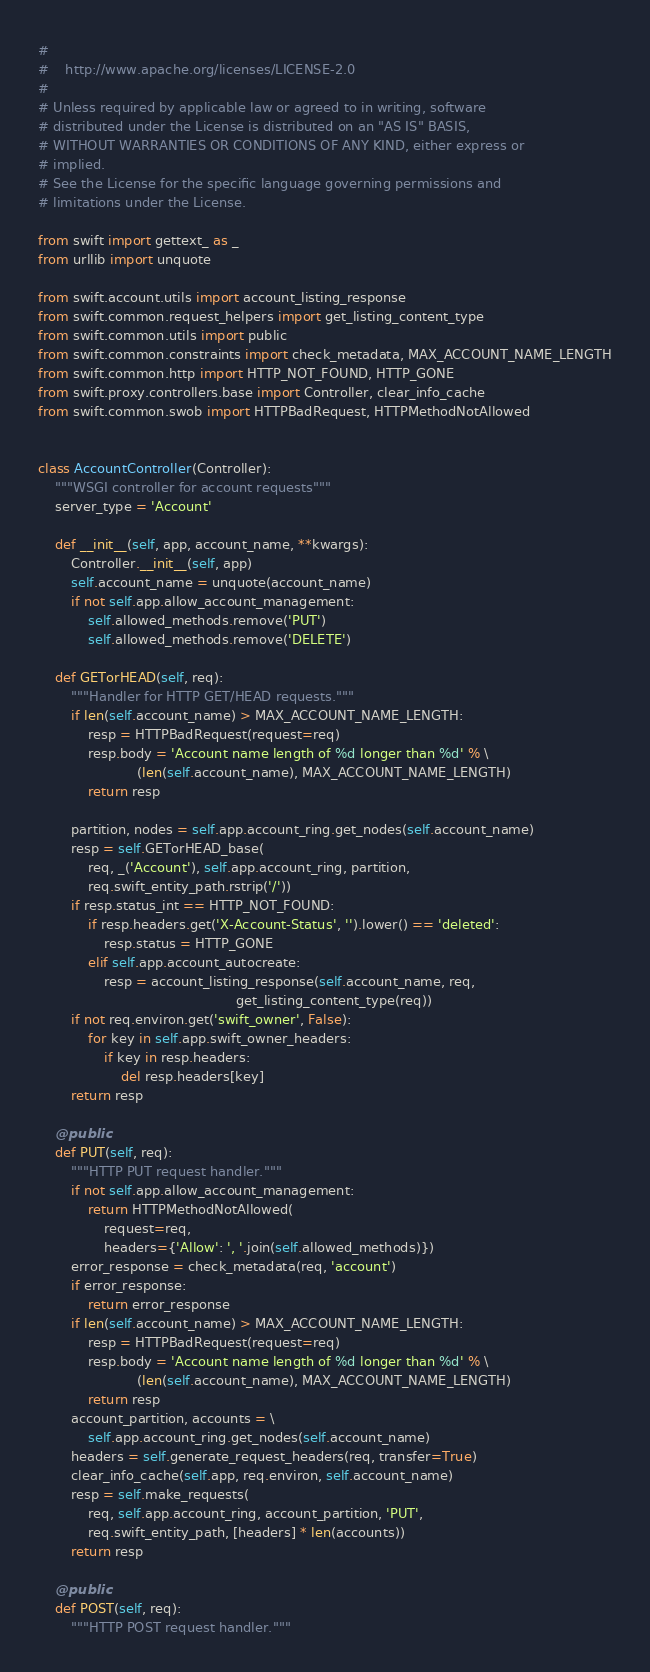<code> <loc_0><loc_0><loc_500><loc_500><_Python_>#
#    http://www.apache.org/licenses/LICENSE-2.0
#
# Unless required by applicable law or agreed to in writing, software
# distributed under the License is distributed on an "AS IS" BASIS,
# WITHOUT WARRANTIES OR CONDITIONS OF ANY KIND, either express or
# implied.
# See the License for the specific language governing permissions and
# limitations under the License.

from swift import gettext_ as _
from urllib import unquote

from swift.account.utils import account_listing_response
from swift.common.request_helpers import get_listing_content_type
from swift.common.utils import public
from swift.common.constraints import check_metadata, MAX_ACCOUNT_NAME_LENGTH
from swift.common.http import HTTP_NOT_FOUND, HTTP_GONE
from swift.proxy.controllers.base import Controller, clear_info_cache
from swift.common.swob import HTTPBadRequest, HTTPMethodNotAllowed


class AccountController(Controller):
    """WSGI controller for account requests"""
    server_type = 'Account'

    def __init__(self, app, account_name, **kwargs):
        Controller.__init__(self, app)
        self.account_name = unquote(account_name)
        if not self.app.allow_account_management:
            self.allowed_methods.remove('PUT')
            self.allowed_methods.remove('DELETE')

    def GETorHEAD(self, req):
        """Handler for HTTP GET/HEAD requests."""
        if len(self.account_name) > MAX_ACCOUNT_NAME_LENGTH:
            resp = HTTPBadRequest(request=req)
            resp.body = 'Account name length of %d longer than %d' % \
                        (len(self.account_name), MAX_ACCOUNT_NAME_LENGTH)
            return resp

        partition, nodes = self.app.account_ring.get_nodes(self.account_name)
        resp = self.GETorHEAD_base(
            req, _('Account'), self.app.account_ring, partition,
            req.swift_entity_path.rstrip('/'))
        if resp.status_int == HTTP_NOT_FOUND:
            if resp.headers.get('X-Account-Status', '').lower() == 'deleted':
                resp.status = HTTP_GONE
            elif self.app.account_autocreate:
                resp = account_listing_response(self.account_name, req,
                                                get_listing_content_type(req))
        if not req.environ.get('swift_owner', False):
            for key in self.app.swift_owner_headers:
                if key in resp.headers:
                    del resp.headers[key]
        return resp

    @public
    def PUT(self, req):
        """HTTP PUT request handler."""
        if not self.app.allow_account_management:
            return HTTPMethodNotAllowed(
                request=req,
                headers={'Allow': ', '.join(self.allowed_methods)})
        error_response = check_metadata(req, 'account')
        if error_response:
            return error_response
        if len(self.account_name) > MAX_ACCOUNT_NAME_LENGTH:
            resp = HTTPBadRequest(request=req)
            resp.body = 'Account name length of %d longer than %d' % \
                        (len(self.account_name), MAX_ACCOUNT_NAME_LENGTH)
            return resp
        account_partition, accounts = \
            self.app.account_ring.get_nodes(self.account_name)
        headers = self.generate_request_headers(req, transfer=True)
        clear_info_cache(self.app, req.environ, self.account_name)
        resp = self.make_requests(
            req, self.app.account_ring, account_partition, 'PUT',
            req.swift_entity_path, [headers] * len(accounts))
        return resp

    @public
    def POST(self, req):
        """HTTP POST request handler."""</code> 